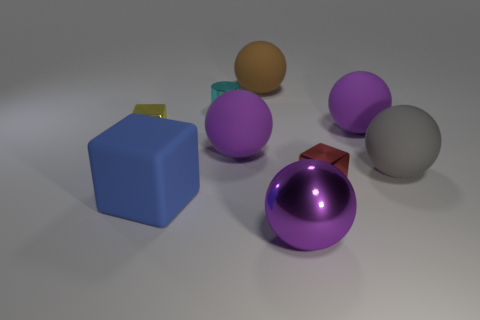There is a rubber ball that is behind the cyan shiny thing; is it the same color as the cylinder?
Ensure brevity in your answer.  No. How many big rubber things have the same color as the shiny ball?
Your answer should be very brief. 2. Is the shape of the thing left of the big blue thing the same as  the big blue rubber object?
Your answer should be very brief. Yes. Are there fewer cyan metal cylinders that are in front of the tiny red block than large brown things that are in front of the large shiny object?
Ensure brevity in your answer.  No. What material is the purple thing to the left of the large brown thing?
Your response must be concise. Rubber. Is there a metallic ball of the same size as the purple metal object?
Offer a terse response. No. There is a tiny cyan metal thing; is it the same shape as the purple metal thing that is in front of the yellow block?
Ensure brevity in your answer.  No. Do the thing that is on the left side of the rubber block and the purple object in front of the red cube have the same size?
Offer a very short reply. No. How many other things are the same shape as the large blue object?
Your response must be concise. 2. What is the material of the purple ball to the left of the big sphere in front of the red block?
Keep it short and to the point. Rubber. 